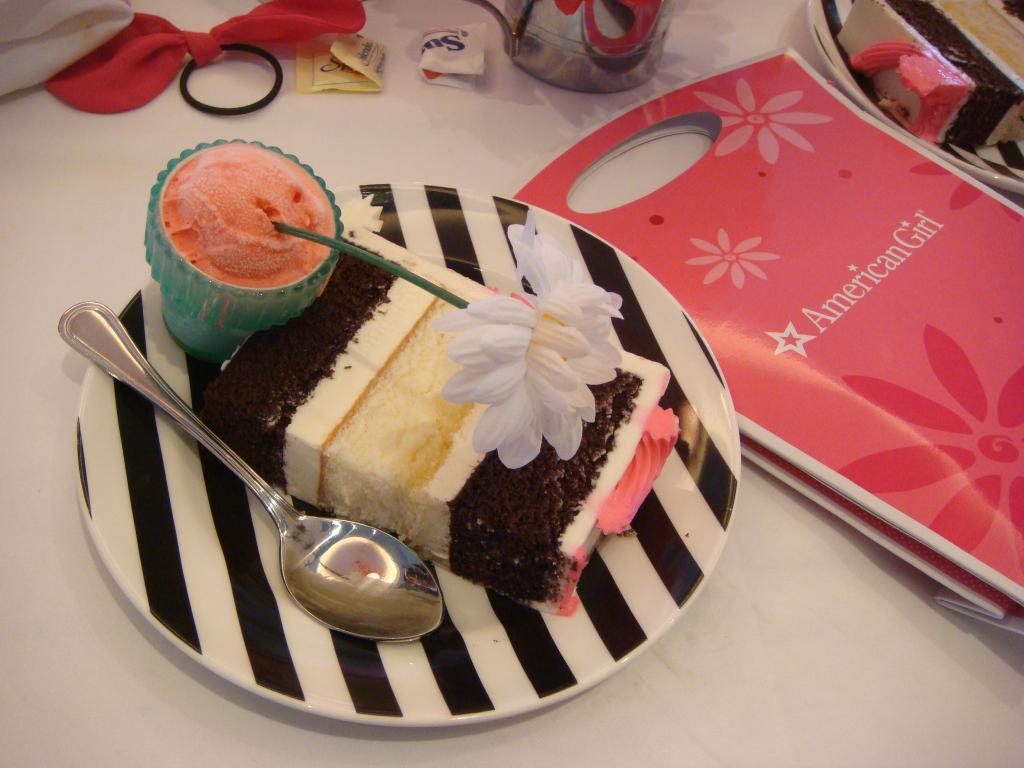Please provide a concise description of this image. In this image we can see two plates containing food and a spoon are placed on the surface. On the right side of the image we can see a bag. At the top of the image we can see a container, some clothes, a ring and sachets placed on the surface. 